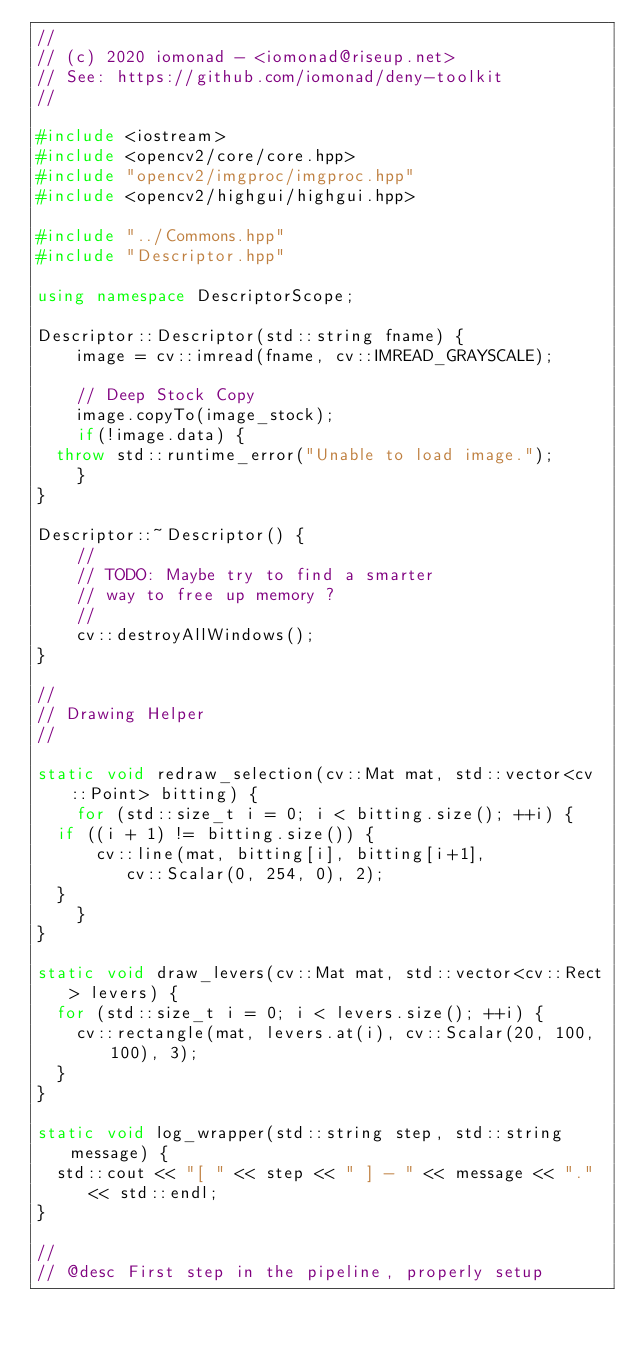<code> <loc_0><loc_0><loc_500><loc_500><_C++_>//
// (c) 2020 iomonad - <iomonad@riseup.net>
// See: https://github.com/iomonad/deny-toolkit
//

#include <iostream>
#include <opencv2/core/core.hpp>
#include "opencv2/imgproc/imgproc.hpp"
#include <opencv2/highgui/highgui.hpp>

#include "../Commons.hpp"
#include "Descriptor.hpp"

using namespace DescriptorScope;

Descriptor::Descriptor(std::string fname) {
    image = cv::imread(fname, cv::IMREAD_GRAYSCALE);

    // Deep Stock Copy
    image.copyTo(image_stock);
    if(!image.data) {
	throw std::runtime_error("Unable to load image.");
    }
}

Descriptor::~Descriptor() {
    //
    // TODO: Maybe try to find a smarter
    // way to free up memory ?
    //
    cv::destroyAllWindows();
}

//
// Drawing Helper
//

static void redraw_selection(cv::Mat mat, std::vector<cv::Point> bitting) {
    for (std::size_t i = 0; i < bitting.size(); ++i) {
	if ((i + 1) != bitting.size()) {
	    cv::line(mat, bitting[i], bitting[i+1],
		     cv::Scalar(0, 254, 0), 2);
	}
    }
}

static void draw_levers(cv::Mat mat, std::vector<cv::Rect> levers) {
	for (std::size_t i = 0; i < levers.size(); ++i) {
		cv::rectangle(mat, levers.at(i), cv::Scalar(20, 100, 100), 3);
	}
}

static void log_wrapper(std::string step, std::string message) {
	std::cout << "[ " << step << " ] - " << message << "." << std::endl;
}

//
// @desc First step in the pipeline, properly setup</code> 